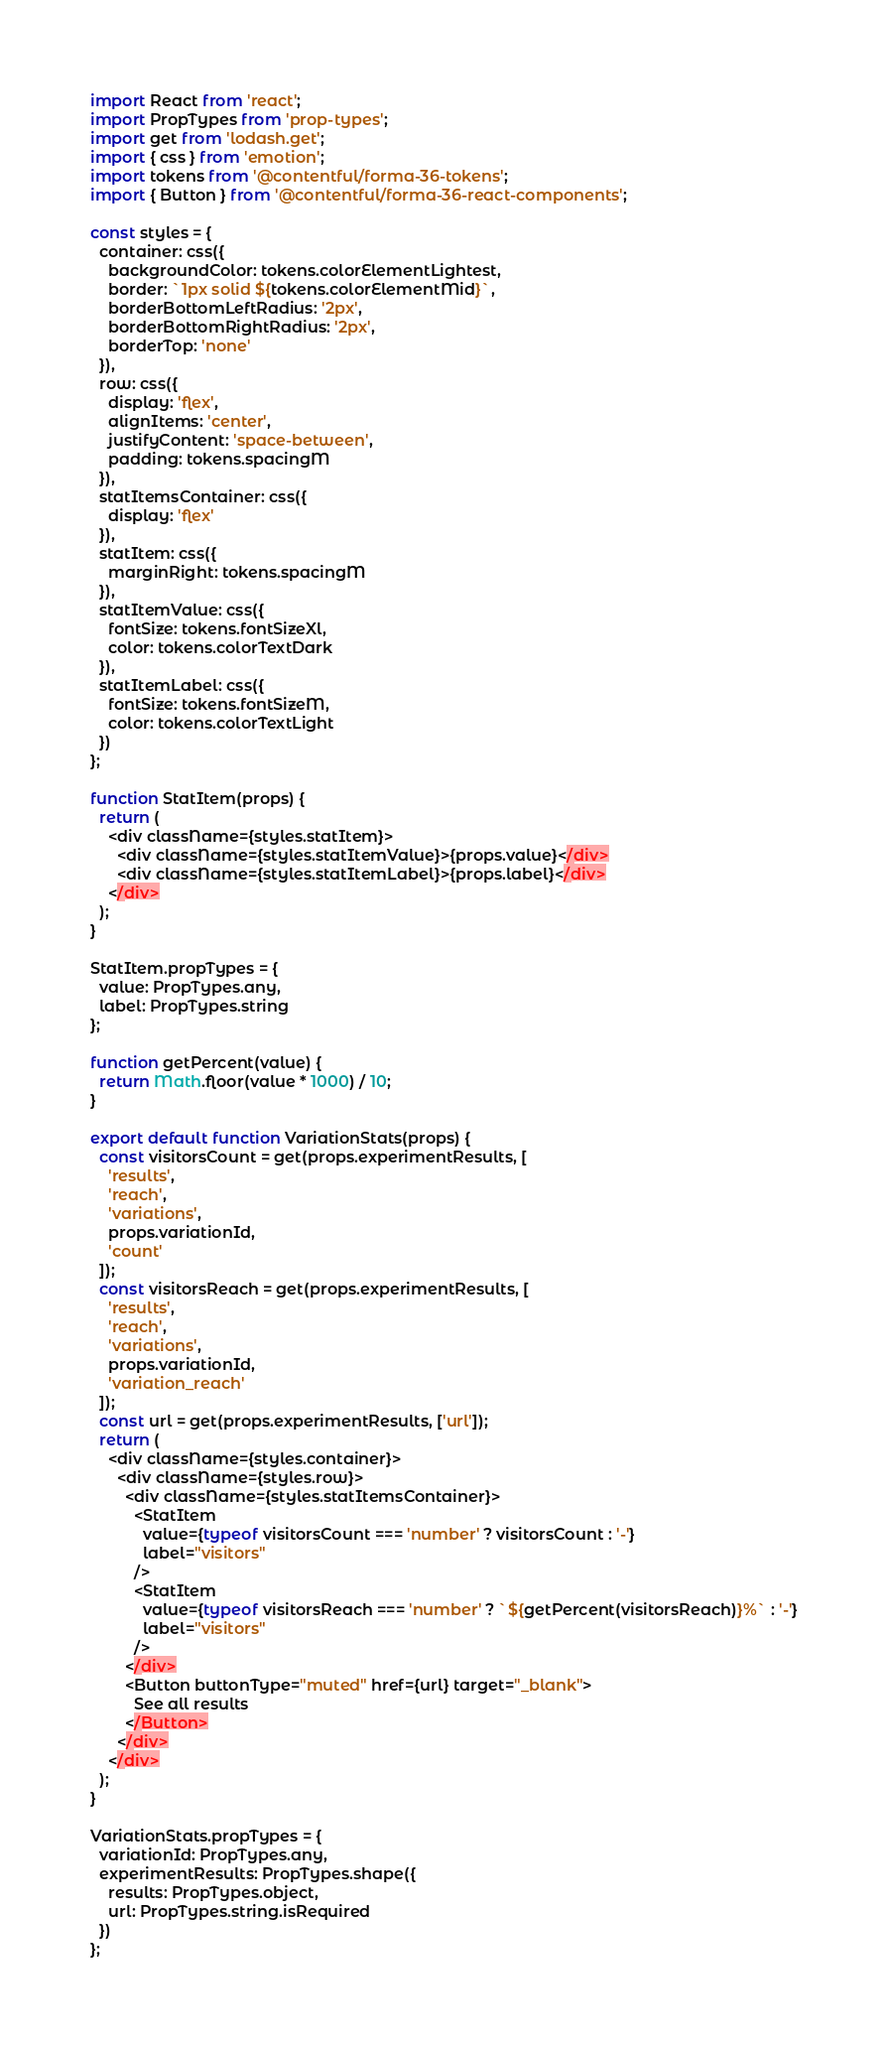<code> <loc_0><loc_0><loc_500><loc_500><_JavaScript_>import React from 'react';
import PropTypes from 'prop-types';
import get from 'lodash.get';
import { css } from 'emotion';
import tokens from '@contentful/forma-36-tokens';
import { Button } from '@contentful/forma-36-react-components';

const styles = {
  container: css({
    backgroundColor: tokens.colorElementLightest,
    border: `1px solid ${tokens.colorElementMid}`,
    borderBottomLeftRadius: '2px',
    borderBottomRightRadius: '2px',
    borderTop: 'none'
  }),
  row: css({
    display: 'flex',
    alignItems: 'center',
    justifyContent: 'space-between',
    padding: tokens.spacingM
  }),
  statItemsContainer: css({
    display: 'flex'
  }),
  statItem: css({
    marginRight: tokens.spacingM
  }),
  statItemValue: css({
    fontSize: tokens.fontSizeXl,
    color: tokens.colorTextDark
  }),
  statItemLabel: css({
    fontSize: tokens.fontSizeM,
    color: tokens.colorTextLight
  })
};

function StatItem(props) {
  return (
    <div className={styles.statItem}>
      <div className={styles.statItemValue}>{props.value}</div>
      <div className={styles.statItemLabel}>{props.label}</div>
    </div>
  );
}

StatItem.propTypes = {
  value: PropTypes.any,
  label: PropTypes.string
};

function getPercent(value) {
  return Math.floor(value * 1000) / 10;
}

export default function VariationStats(props) {
  const visitorsCount = get(props.experimentResults, [
    'results',
    'reach',
    'variations',
    props.variationId,
    'count'
  ]);
  const visitorsReach = get(props.experimentResults, [
    'results',
    'reach',
    'variations',
    props.variationId,
    'variation_reach'
  ]);
  const url = get(props.experimentResults, ['url']);
  return (
    <div className={styles.container}>
      <div className={styles.row}>
        <div className={styles.statItemsContainer}>
          <StatItem
            value={typeof visitorsCount === 'number' ? visitorsCount : '-'}
            label="visitors"
          />
          <StatItem
            value={typeof visitorsReach === 'number' ? `${getPercent(visitorsReach)}%` : '-'}
            label="visitors"
          />
        </div>
        <Button buttonType="muted" href={url} target="_blank">
          See all results
        </Button>
      </div>
    </div>
  );
}

VariationStats.propTypes = {
  variationId: PropTypes.any,
  experimentResults: PropTypes.shape({
    results: PropTypes.object,
    url: PropTypes.string.isRequired
  })
};
</code> 